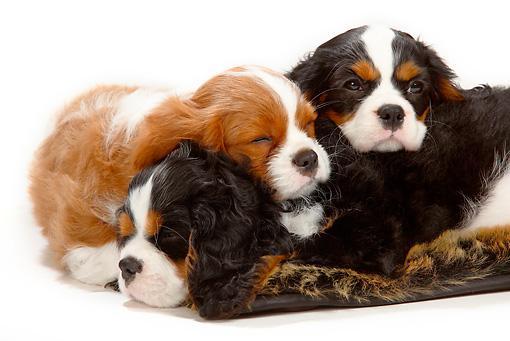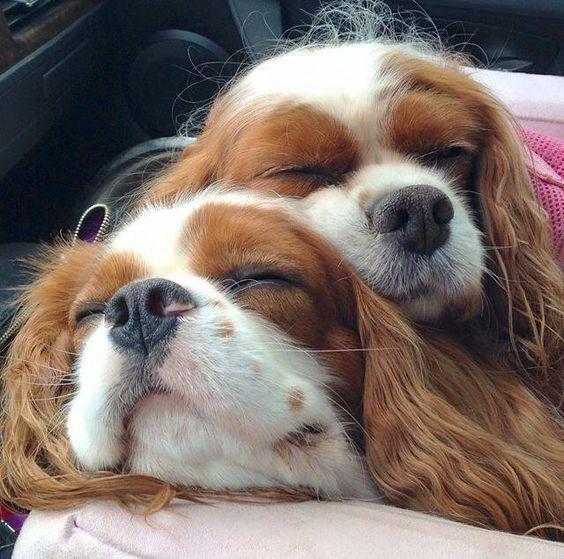The first image is the image on the left, the second image is the image on the right. For the images shown, is this caption "One image shows a trio of reclining puppies, with the middle one flanked by two dogs with matching coloring." true? Answer yes or no. Yes. The first image is the image on the left, the second image is the image on the right. For the images displayed, is the sentence "There are more dogs in the image on the left than in the image on the right." factually correct? Answer yes or no. Yes. 